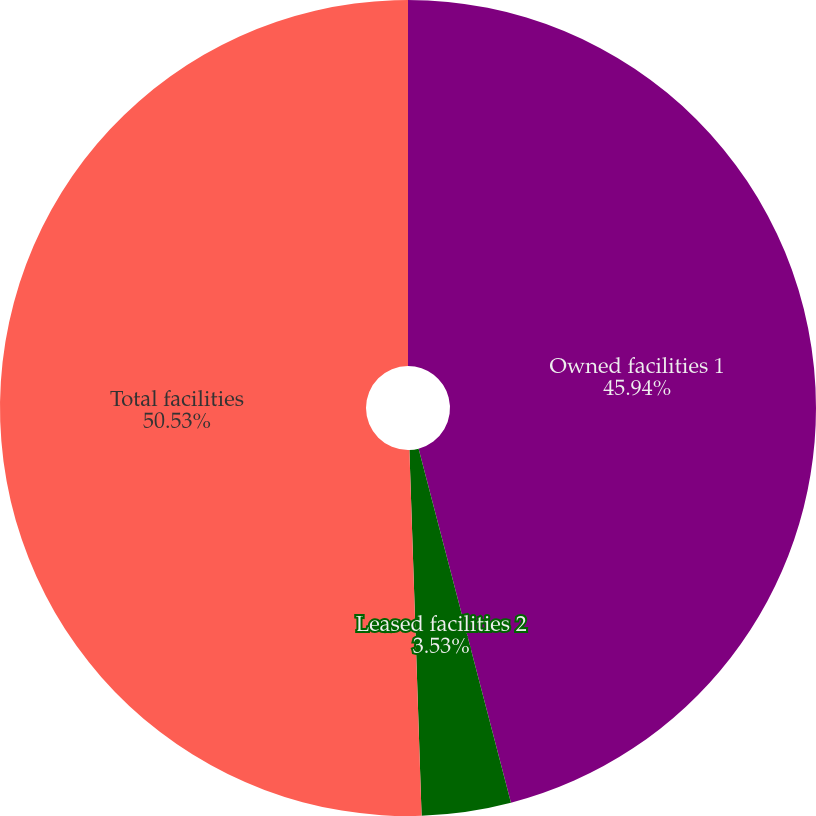Convert chart to OTSL. <chart><loc_0><loc_0><loc_500><loc_500><pie_chart><fcel>Owned facilities 1<fcel>Leased facilities 2<fcel>Total facilities<nl><fcel>45.94%<fcel>3.53%<fcel>50.53%<nl></chart> 